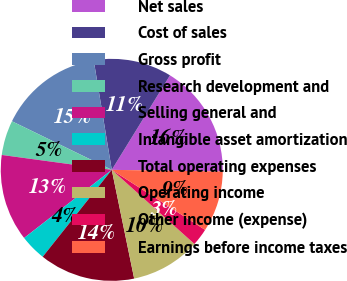Convert chart to OTSL. <chart><loc_0><loc_0><loc_500><loc_500><pie_chart><fcel>Net sales<fcel>Cost of sales<fcel>Gross profit<fcel>Research development and<fcel>Selling general and<fcel>Intangible asset amortization<fcel>Total operating expenses<fcel>Operating income<fcel>Other income (expense)<fcel>Earnings before income taxes<nl><fcel>16.45%<fcel>11.39%<fcel>15.19%<fcel>5.07%<fcel>12.66%<fcel>3.8%<fcel>13.92%<fcel>10.13%<fcel>2.54%<fcel>8.86%<nl></chart> 